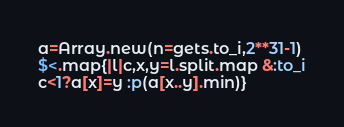<code> <loc_0><loc_0><loc_500><loc_500><_Ruby_>a=Array.new(n=gets.to_i,2**31-1)
$<.map{|l|c,x,y=l.split.map &:to_i
c<1?a[x]=y :p(a[x..y].min)}</code> 